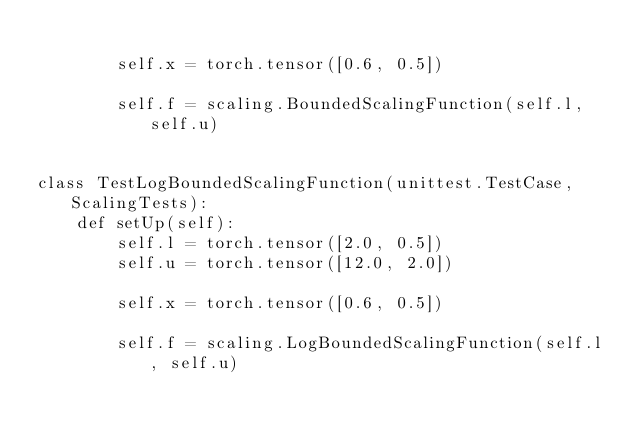<code> <loc_0><loc_0><loc_500><loc_500><_Python_>
        self.x = torch.tensor([0.6, 0.5])

        self.f = scaling.BoundedScalingFunction(self.l, self.u)


class TestLogBoundedScalingFunction(unittest.TestCase, ScalingTests):
    def setUp(self):
        self.l = torch.tensor([2.0, 0.5])
        self.u = torch.tensor([12.0, 2.0])

        self.x = torch.tensor([0.6, 0.5])

        self.f = scaling.LogBoundedScalingFunction(self.l, self.u)
</code> 